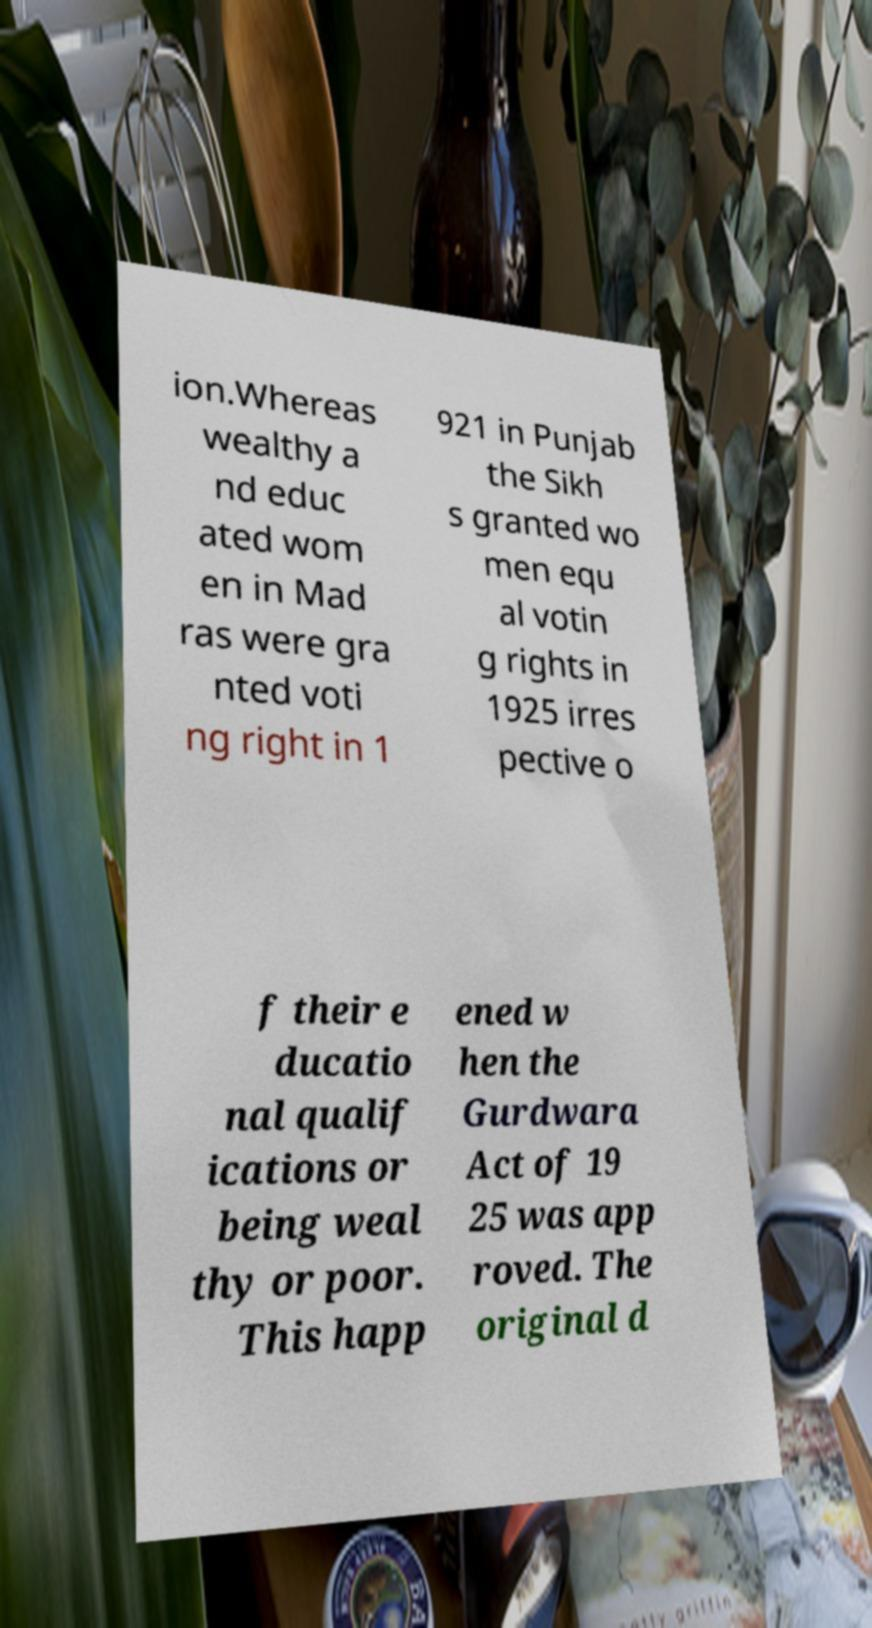Can you accurately transcribe the text from the provided image for me? ion.Whereas wealthy a nd educ ated wom en in Mad ras were gra nted voti ng right in 1 921 in Punjab the Sikh s granted wo men equ al votin g rights in 1925 irres pective o f their e ducatio nal qualif ications or being weal thy or poor. This happ ened w hen the Gurdwara Act of 19 25 was app roved. The original d 